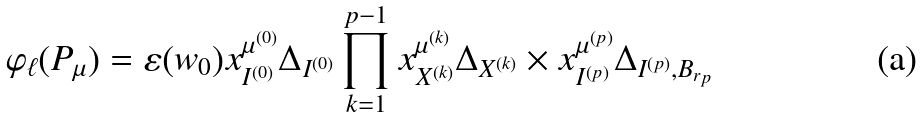Convert formula to latex. <formula><loc_0><loc_0><loc_500><loc_500>\varphi _ { \ell } ( P _ { \mu } ) = \varepsilon ( w _ { 0 } ) x _ { I ^ { ( 0 ) } } ^ { \mu ^ { ( 0 ) } } \Delta _ { I ^ { ( 0 ) } } \prod _ { k = 1 } ^ { p - 1 } x _ { X ^ { ( k ) } } ^ { \mu ^ { ( k ) } } \Delta _ { X ^ { ( k ) } } \times x _ { I ^ { ( p ) } } ^ { \mu ^ { ( p ) } } \Delta _ { I ^ { ( p ) } , B _ { r _ { p } } }</formula> 